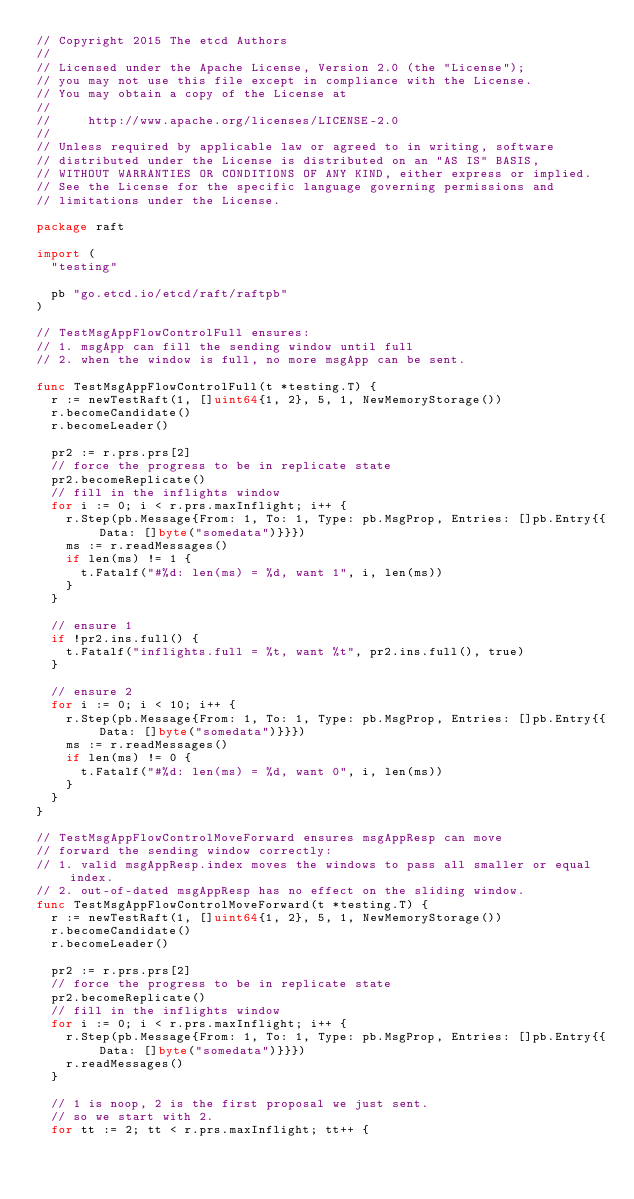Convert code to text. <code><loc_0><loc_0><loc_500><loc_500><_Go_>// Copyright 2015 The etcd Authors
//
// Licensed under the Apache License, Version 2.0 (the "License");
// you may not use this file except in compliance with the License.
// You may obtain a copy of the License at
//
//     http://www.apache.org/licenses/LICENSE-2.0
//
// Unless required by applicable law or agreed to in writing, software
// distributed under the License is distributed on an "AS IS" BASIS,
// WITHOUT WARRANTIES OR CONDITIONS OF ANY KIND, either express or implied.
// See the License for the specific language governing permissions and
// limitations under the License.

package raft

import (
	"testing"

	pb "go.etcd.io/etcd/raft/raftpb"
)

// TestMsgAppFlowControlFull ensures:
// 1. msgApp can fill the sending window until full
// 2. when the window is full, no more msgApp can be sent.

func TestMsgAppFlowControlFull(t *testing.T) {
	r := newTestRaft(1, []uint64{1, 2}, 5, 1, NewMemoryStorage())
	r.becomeCandidate()
	r.becomeLeader()

	pr2 := r.prs.prs[2]
	// force the progress to be in replicate state
	pr2.becomeReplicate()
	// fill in the inflights window
	for i := 0; i < r.prs.maxInflight; i++ {
		r.Step(pb.Message{From: 1, To: 1, Type: pb.MsgProp, Entries: []pb.Entry{{Data: []byte("somedata")}}})
		ms := r.readMessages()
		if len(ms) != 1 {
			t.Fatalf("#%d: len(ms) = %d, want 1", i, len(ms))
		}
	}

	// ensure 1
	if !pr2.ins.full() {
		t.Fatalf("inflights.full = %t, want %t", pr2.ins.full(), true)
	}

	// ensure 2
	for i := 0; i < 10; i++ {
		r.Step(pb.Message{From: 1, To: 1, Type: pb.MsgProp, Entries: []pb.Entry{{Data: []byte("somedata")}}})
		ms := r.readMessages()
		if len(ms) != 0 {
			t.Fatalf("#%d: len(ms) = %d, want 0", i, len(ms))
		}
	}
}

// TestMsgAppFlowControlMoveForward ensures msgAppResp can move
// forward the sending window correctly:
// 1. valid msgAppResp.index moves the windows to pass all smaller or equal index.
// 2. out-of-dated msgAppResp has no effect on the sliding window.
func TestMsgAppFlowControlMoveForward(t *testing.T) {
	r := newTestRaft(1, []uint64{1, 2}, 5, 1, NewMemoryStorage())
	r.becomeCandidate()
	r.becomeLeader()

	pr2 := r.prs.prs[2]
	// force the progress to be in replicate state
	pr2.becomeReplicate()
	// fill in the inflights window
	for i := 0; i < r.prs.maxInflight; i++ {
		r.Step(pb.Message{From: 1, To: 1, Type: pb.MsgProp, Entries: []pb.Entry{{Data: []byte("somedata")}}})
		r.readMessages()
	}

	// 1 is noop, 2 is the first proposal we just sent.
	// so we start with 2.
	for tt := 2; tt < r.prs.maxInflight; tt++ {</code> 